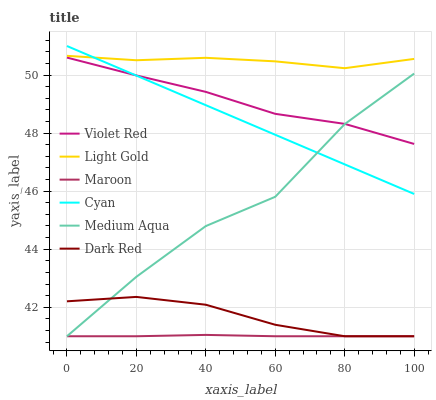Does Maroon have the minimum area under the curve?
Answer yes or no. Yes. Does Light Gold have the maximum area under the curve?
Answer yes or no. Yes. Does Dark Red have the minimum area under the curve?
Answer yes or no. No. Does Dark Red have the maximum area under the curve?
Answer yes or no. No. Is Cyan the smoothest?
Answer yes or no. Yes. Is Medium Aqua the roughest?
Answer yes or no. Yes. Is Dark Red the smoothest?
Answer yes or no. No. Is Dark Red the roughest?
Answer yes or no. No. Does Dark Red have the lowest value?
Answer yes or no. Yes. Does Cyan have the lowest value?
Answer yes or no. No. Does Cyan have the highest value?
Answer yes or no. Yes. Does Dark Red have the highest value?
Answer yes or no. No. Is Dark Red less than Light Gold?
Answer yes or no. Yes. Is Cyan greater than Maroon?
Answer yes or no. Yes. Does Dark Red intersect Maroon?
Answer yes or no. Yes. Is Dark Red less than Maroon?
Answer yes or no. No. Is Dark Red greater than Maroon?
Answer yes or no. No. Does Dark Red intersect Light Gold?
Answer yes or no. No. 